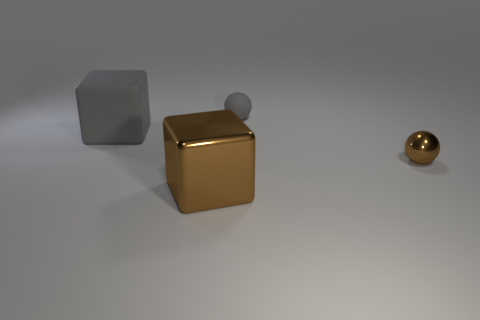Add 3 tiny brown things. How many objects exist? 7 Add 1 large metal blocks. How many large metal blocks exist? 2 Subtract 0 yellow cylinders. How many objects are left? 4 Subtract all matte blocks. Subtract all tiny brown metal objects. How many objects are left? 2 Add 2 tiny balls. How many tiny balls are left? 4 